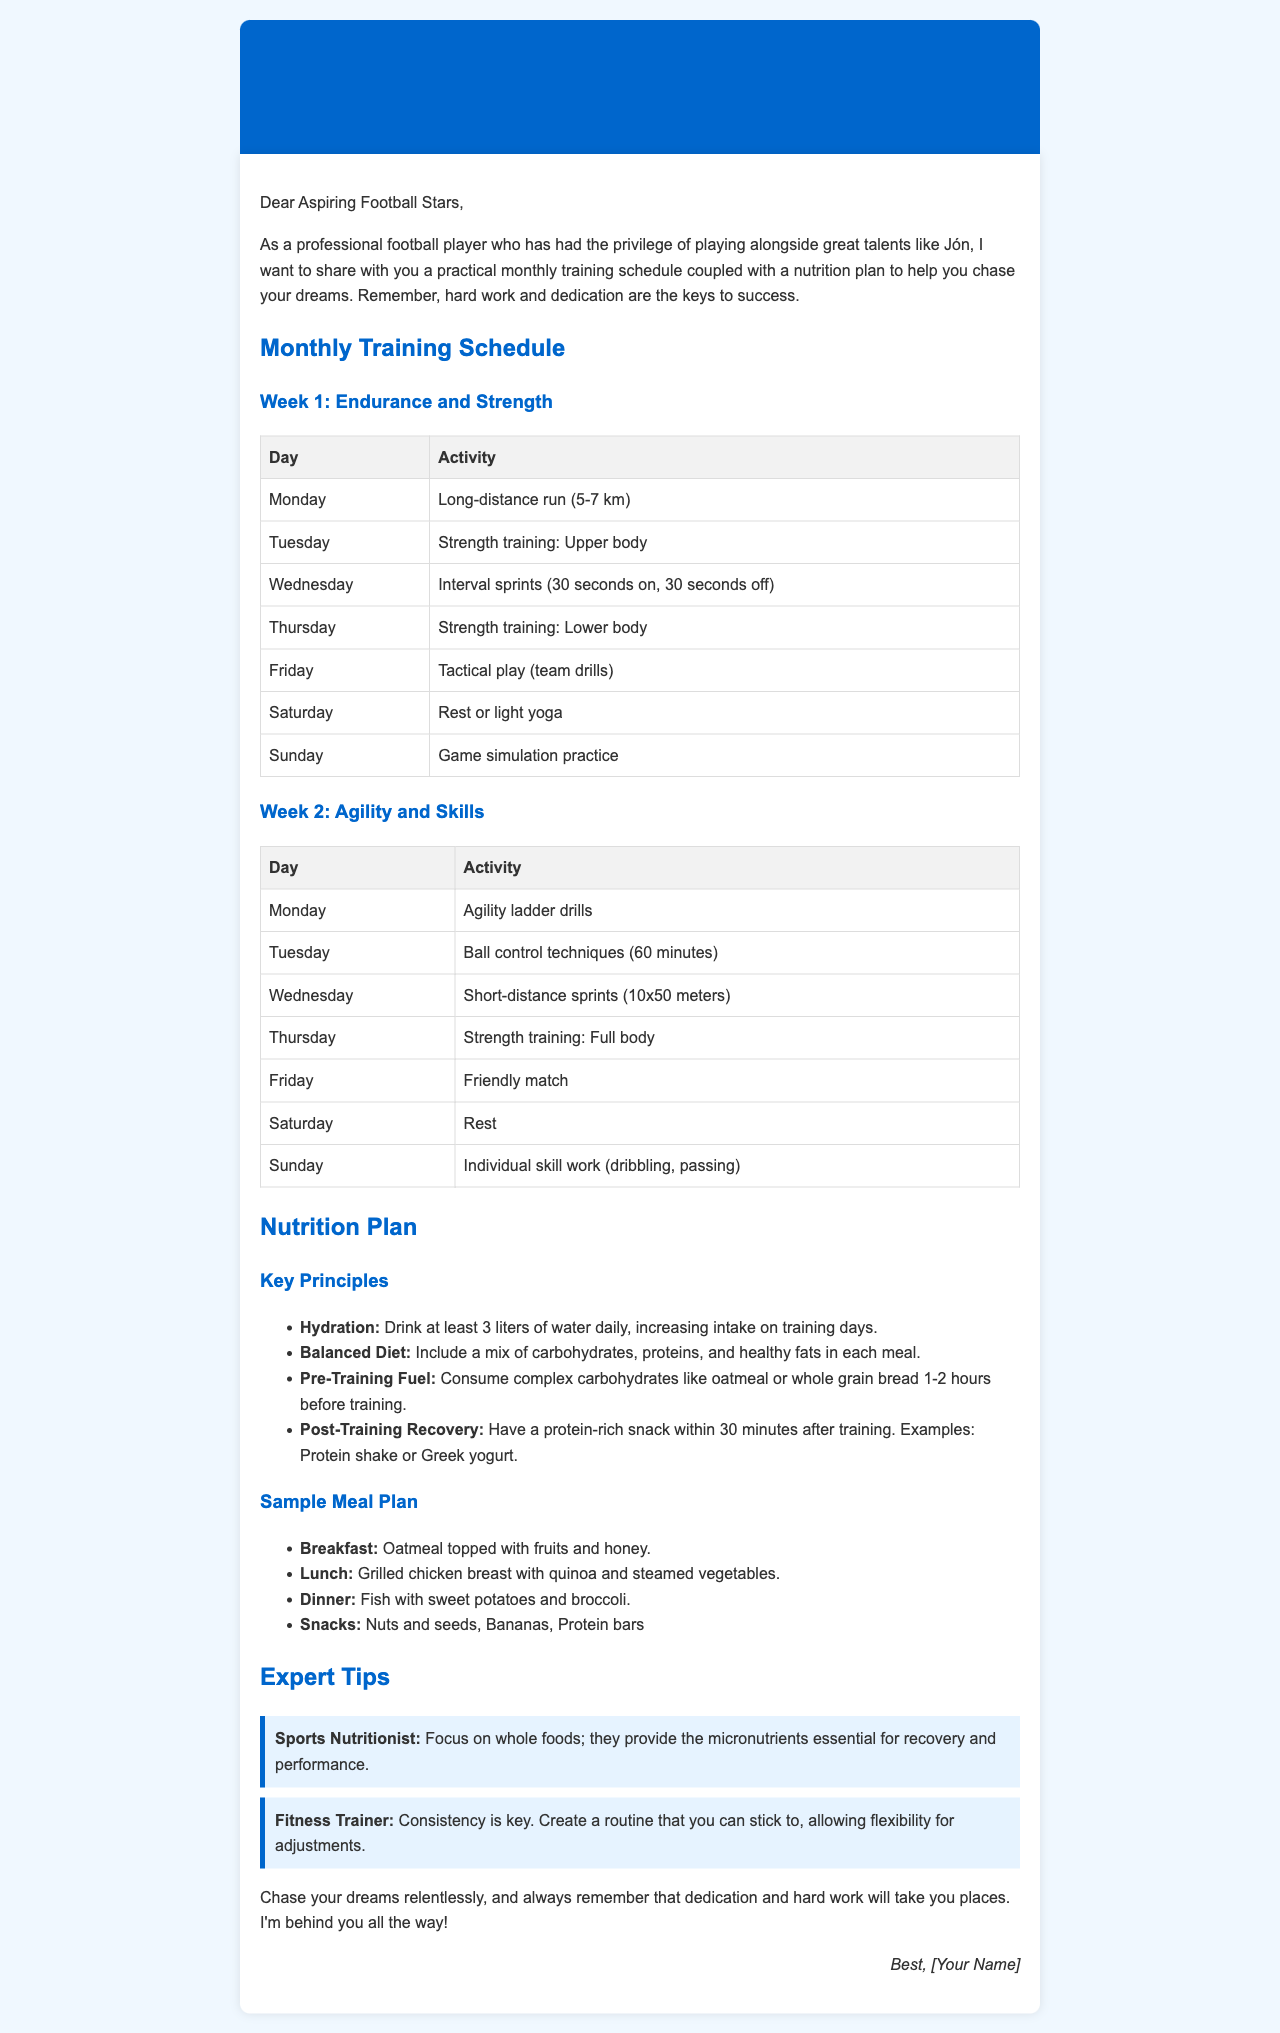What is the total distance for the long-distance run on Monday of Week 1? The long-distance run distance is mentioned as 5-7 km for Monday in Week 1 of the training schedule.
Answer: 5-7 km What activity is scheduled for Wednesday in Week 2? The activity for Wednesday in Week 2 is described in the training schedule, which is "Short-distance sprints (10x50 meters)."
Answer: Short-distance sprints How many liters of water should be consumed daily? The document states that at least 3 liters of water should be consumed daily, which is a guideline for hydration.
Answer: 3 liters What type of meal is suggested for breakfast? The nutrition plan specifies "Oatmeal topped with fruits and honey" for breakfast.
Answer: Oatmeal topped with fruits and honey Who provides the tip about focusing on whole foods? The tip about focusing on whole foods is attributed to a "Sports Nutritionist" in the expert tips section.
Answer: Sports Nutritionist What is the recommended post-training recovery snack? The document suggests having a protein-rich snack like "Protein shake or Greek yogurt" within 30 minutes after training.
Answer: Protein shake or Greek yogurt What is the main focus of the second week's training schedule? The main focus for week 2 is stated as "Agility and Skills," which is the theme of the activities planned for that week.
Answer: Agility and Skills What exercise is recommended for Saturday in Week 1? On Saturday in Week 1, the document suggests "Rest or light yoga" as the planned activity.
Answer: Rest or light yoga What meal is suggested for dinner? The suggested dinner in the sample meal plan is "Fish with sweet potatoes and broccoli."
Answer: Fish with sweet potatoes and broccoli 